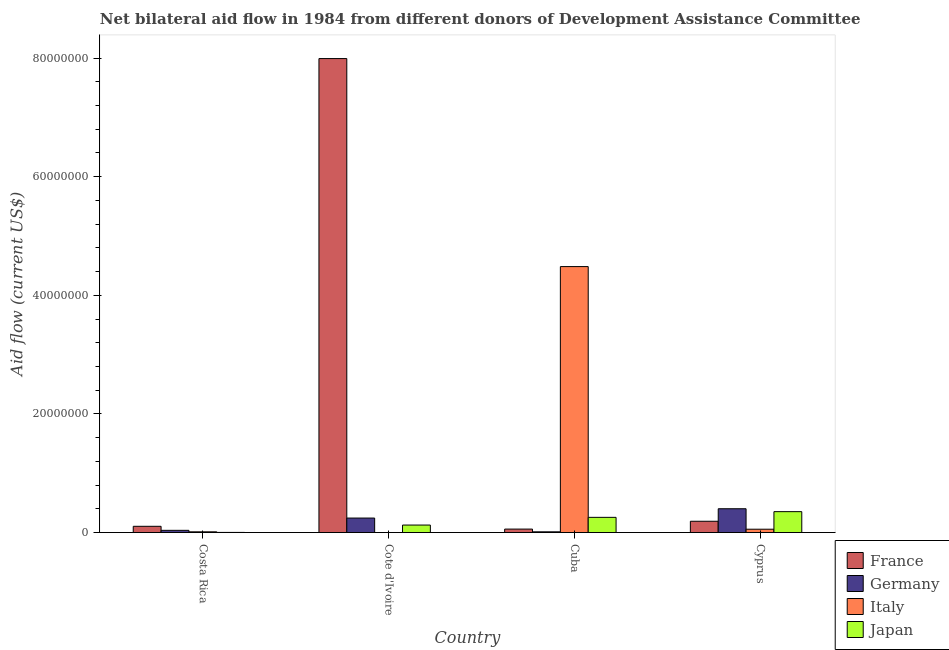How many different coloured bars are there?
Keep it short and to the point. 4. How many bars are there on the 4th tick from the left?
Offer a terse response. 4. How many bars are there on the 1st tick from the right?
Provide a succinct answer. 4. What is the label of the 4th group of bars from the left?
Make the answer very short. Cyprus. In how many cases, is the number of bars for a given country not equal to the number of legend labels?
Make the answer very short. 0. What is the amount of aid given by france in Cote d'Ivoire?
Make the answer very short. 7.99e+07. Across all countries, what is the maximum amount of aid given by germany?
Keep it short and to the point. 4.02e+06. Across all countries, what is the minimum amount of aid given by japan?
Keep it short and to the point. 3.00e+04. In which country was the amount of aid given by france maximum?
Keep it short and to the point. Cote d'Ivoire. In which country was the amount of aid given by germany minimum?
Your response must be concise. Cuba. What is the total amount of aid given by germany in the graph?
Offer a terse response. 6.98e+06. What is the difference between the amount of aid given by italy in Costa Rica and that in Cuba?
Offer a terse response. -4.47e+07. What is the difference between the amount of aid given by japan in Costa Rica and the amount of aid given by france in Cote d'Ivoire?
Your answer should be very brief. -7.99e+07. What is the average amount of aid given by germany per country?
Ensure brevity in your answer.  1.74e+06. What is the difference between the amount of aid given by france and amount of aid given by germany in Cote d'Ivoire?
Your answer should be very brief. 7.75e+07. What is the ratio of the amount of aid given by germany in Costa Rica to that in Cuba?
Offer a terse response. 2.92. What is the difference between the highest and the second highest amount of aid given by germany?
Keep it short and to the point. 1.57e+06. What is the difference between the highest and the lowest amount of aid given by france?
Offer a very short reply. 7.93e+07. In how many countries, is the amount of aid given by france greater than the average amount of aid given by france taken over all countries?
Provide a succinct answer. 1. Is it the case that in every country, the sum of the amount of aid given by japan and amount of aid given by germany is greater than the sum of amount of aid given by france and amount of aid given by italy?
Your answer should be compact. No. What does the 4th bar from the left in Costa Rica represents?
Provide a short and direct response. Japan. What does the 4th bar from the right in Cote d'Ivoire represents?
Ensure brevity in your answer.  France. Are all the bars in the graph horizontal?
Provide a succinct answer. No. What is the difference between two consecutive major ticks on the Y-axis?
Offer a very short reply. 2.00e+07. Are the values on the major ticks of Y-axis written in scientific E-notation?
Make the answer very short. No. Does the graph contain any zero values?
Keep it short and to the point. No. Does the graph contain grids?
Offer a terse response. No. Where does the legend appear in the graph?
Your answer should be compact. Bottom right. How many legend labels are there?
Give a very brief answer. 4. What is the title of the graph?
Offer a terse response. Net bilateral aid flow in 1984 from different donors of Development Assistance Committee. What is the label or title of the X-axis?
Keep it short and to the point. Country. What is the Aid flow (current US$) of France in Costa Rica?
Make the answer very short. 1.06e+06. What is the Aid flow (current US$) of Japan in Costa Rica?
Your response must be concise. 3.00e+04. What is the Aid flow (current US$) of France in Cote d'Ivoire?
Provide a short and direct response. 7.99e+07. What is the Aid flow (current US$) of Germany in Cote d'Ivoire?
Your answer should be compact. 2.45e+06. What is the Aid flow (current US$) of Japan in Cote d'Ivoire?
Ensure brevity in your answer.  1.27e+06. What is the Aid flow (current US$) in France in Cuba?
Make the answer very short. 5.90e+05. What is the Aid flow (current US$) in Germany in Cuba?
Offer a very short reply. 1.30e+05. What is the Aid flow (current US$) in Italy in Cuba?
Provide a succinct answer. 4.48e+07. What is the Aid flow (current US$) of Japan in Cuba?
Your response must be concise. 2.57e+06. What is the Aid flow (current US$) of France in Cyprus?
Your response must be concise. 1.91e+06. What is the Aid flow (current US$) of Germany in Cyprus?
Give a very brief answer. 4.02e+06. What is the Aid flow (current US$) in Italy in Cyprus?
Keep it short and to the point. 5.70e+05. What is the Aid flow (current US$) in Japan in Cyprus?
Ensure brevity in your answer.  3.53e+06. Across all countries, what is the maximum Aid flow (current US$) in France?
Your answer should be very brief. 7.99e+07. Across all countries, what is the maximum Aid flow (current US$) in Germany?
Provide a short and direct response. 4.02e+06. Across all countries, what is the maximum Aid flow (current US$) in Italy?
Offer a very short reply. 4.48e+07. Across all countries, what is the maximum Aid flow (current US$) of Japan?
Offer a terse response. 3.53e+06. Across all countries, what is the minimum Aid flow (current US$) in France?
Give a very brief answer. 5.90e+05. Across all countries, what is the minimum Aid flow (current US$) of Germany?
Ensure brevity in your answer.  1.30e+05. Across all countries, what is the minimum Aid flow (current US$) in Japan?
Make the answer very short. 3.00e+04. What is the total Aid flow (current US$) in France in the graph?
Your response must be concise. 8.35e+07. What is the total Aid flow (current US$) of Germany in the graph?
Provide a succinct answer. 6.98e+06. What is the total Aid flow (current US$) of Italy in the graph?
Your response must be concise. 4.56e+07. What is the total Aid flow (current US$) of Japan in the graph?
Offer a terse response. 7.40e+06. What is the difference between the Aid flow (current US$) in France in Costa Rica and that in Cote d'Ivoire?
Your answer should be compact. -7.89e+07. What is the difference between the Aid flow (current US$) of Germany in Costa Rica and that in Cote d'Ivoire?
Keep it short and to the point. -2.07e+06. What is the difference between the Aid flow (current US$) in Italy in Costa Rica and that in Cote d'Ivoire?
Make the answer very short. 1.20e+05. What is the difference between the Aid flow (current US$) in Japan in Costa Rica and that in Cote d'Ivoire?
Keep it short and to the point. -1.24e+06. What is the difference between the Aid flow (current US$) in France in Costa Rica and that in Cuba?
Ensure brevity in your answer.  4.70e+05. What is the difference between the Aid flow (current US$) in Italy in Costa Rica and that in Cuba?
Provide a succinct answer. -4.47e+07. What is the difference between the Aid flow (current US$) in Japan in Costa Rica and that in Cuba?
Your response must be concise. -2.54e+06. What is the difference between the Aid flow (current US$) of France in Costa Rica and that in Cyprus?
Offer a very short reply. -8.50e+05. What is the difference between the Aid flow (current US$) in Germany in Costa Rica and that in Cyprus?
Ensure brevity in your answer.  -3.64e+06. What is the difference between the Aid flow (current US$) of Italy in Costa Rica and that in Cyprus?
Provide a succinct answer. -4.40e+05. What is the difference between the Aid flow (current US$) in Japan in Costa Rica and that in Cyprus?
Offer a very short reply. -3.50e+06. What is the difference between the Aid flow (current US$) of France in Cote d'Ivoire and that in Cuba?
Keep it short and to the point. 7.93e+07. What is the difference between the Aid flow (current US$) of Germany in Cote d'Ivoire and that in Cuba?
Your answer should be compact. 2.32e+06. What is the difference between the Aid flow (current US$) in Italy in Cote d'Ivoire and that in Cuba?
Keep it short and to the point. -4.48e+07. What is the difference between the Aid flow (current US$) of Japan in Cote d'Ivoire and that in Cuba?
Provide a short and direct response. -1.30e+06. What is the difference between the Aid flow (current US$) in France in Cote d'Ivoire and that in Cyprus?
Provide a succinct answer. 7.80e+07. What is the difference between the Aid flow (current US$) in Germany in Cote d'Ivoire and that in Cyprus?
Offer a very short reply. -1.57e+06. What is the difference between the Aid flow (current US$) of Italy in Cote d'Ivoire and that in Cyprus?
Your response must be concise. -5.60e+05. What is the difference between the Aid flow (current US$) of Japan in Cote d'Ivoire and that in Cyprus?
Your response must be concise. -2.26e+06. What is the difference between the Aid flow (current US$) of France in Cuba and that in Cyprus?
Offer a very short reply. -1.32e+06. What is the difference between the Aid flow (current US$) of Germany in Cuba and that in Cyprus?
Ensure brevity in your answer.  -3.89e+06. What is the difference between the Aid flow (current US$) of Italy in Cuba and that in Cyprus?
Keep it short and to the point. 4.43e+07. What is the difference between the Aid flow (current US$) of Japan in Cuba and that in Cyprus?
Your response must be concise. -9.60e+05. What is the difference between the Aid flow (current US$) in France in Costa Rica and the Aid flow (current US$) in Germany in Cote d'Ivoire?
Provide a short and direct response. -1.39e+06. What is the difference between the Aid flow (current US$) of France in Costa Rica and the Aid flow (current US$) of Italy in Cote d'Ivoire?
Ensure brevity in your answer.  1.05e+06. What is the difference between the Aid flow (current US$) in Germany in Costa Rica and the Aid flow (current US$) in Italy in Cote d'Ivoire?
Provide a short and direct response. 3.70e+05. What is the difference between the Aid flow (current US$) of Germany in Costa Rica and the Aid flow (current US$) of Japan in Cote d'Ivoire?
Your response must be concise. -8.90e+05. What is the difference between the Aid flow (current US$) in Italy in Costa Rica and the Aid flow (current US$) in Japan in Cote d'Ivoire?
Ensure brevity in your answer.  -1.14e+06. What is the difference between the Aid flow (current US$) of France in Costa Rica and the Aid flow (current US$) of Germany in Cuba?
Your answer should be very brief. 9.30e+05. What is the difference between the Aid flow (current US$) of France in Costa Rica and the Aid flow (current US$) of Italy in Cuba?
Keep it short and to the point. -4.38e+07. What is the difference between the Aid flow (current US$) of France in Costa Rica and the Aid flow (current US$) of Japan in Cuba?
Give a very brief answer. -1.51e+06. What is the difference between the Aid flow (current US$) of Germany in Costa Rica and the Aid flow (current US$) of Italy in Cuba?
Keep it short and to the point. -4.45e+07. What is the difference between the Aid flow (current US$) in Germany in Costa Rica and the Aid flow (current US$) in Japan in Cuba?
Keep it short and to the point. -2.19e+06. What is the difference between the Aid flow (current US$) of Italy in Costa Rica and the Aid flow (current US$) of Japan in Cuba?
Give a very brief answer. -2.44e+06. What is the difference between the Aid flow (current US$) in France in Costa Rica and the Aid flow (current US$) in Germany in Cyprus?
Ensure brevity in your answer.  -2.96e+06. What is the difference between the Aid flow (current US$) of France in Costa Rica and the Aid flow (current US$) of Italy in Cyprus?
Provide a short and direct response. 4.90e+05. What is the difference between the Aid flow (current US$) of France in Costa Rica and the Aid flow (current US$) of Japan in Cyprus?
Keep it short and to the point. -2.47e+06. What is the difference between the Aid flow (current US$) in Germany in Costa Rica and the Aid flow (current US$) in Japan in Cyprus?
Ensure brevity in your answer.  -3.15e+06. What is the difference between the Aid flow (current US$) in Italy in Costa Rica and the Aid flow (current US$) in Japan in Cyprus?
Provide a succinct answer. -3.40e+06. What is the difference between the Aid flow (current US$) in France in Cote d'Ivoire and the Aid flow (current US$) in Germany in Cuba?
Your answer should be very brief. 7.98e+07. What is the difference between the Aid flow (current US$) in France in Cote d'Ivoire and the Aid flow (current US$) in Italy in Cuba?
Your answer should be compact. 3.51e+07. What is the difference between the Aid flow (current US$) of France in Cote d'Ivoire and the Aid flow (current US$) of Japan in Cuba?
Your answer should be compact. 7.74e+07. What is the difference between the Aid flow (current US$) of Germany in Cote d'Ivoire and the Aid flow (current US$) of Italy in Cuba?
Make the answer very short. -4.24e+07. What is the difference between the Aid flow (current US$) of Italy in Cote d'Ivoire and the Aid flow (current US$) of Japan in Cuba?
Offer a terse response. -2.56e+06. What is the difference between the Aid flow (current US$) in France in Cote d'Ivoire and the Aid flow (current US$) in Germany in Cyprus?
Your answer should be compact. 7.59e+07. What is the difference between the Aid flow (current US$) in France in Cote d'Ivoire and the Aid flow (current US$) in Italy in Cyprus?
Provide a succinct answer. 7.94e+07. What is the difference between the Aid flow (current US$) in France in Cote d'Ivoire and the Aid flow (current US$) in Japan in Cyprus?
Provide a short and direct response. 7.64e+07. What is the difference between the Aid flow (current US$) of Germany in Cote d'Ivoire and the Aid flow (current US$) of Italy in Cyprus?
Provide a short and direct response. 1.88e+06. What is the difference between the Aid flow (current US$) in Germany in Cote d'Ivoire and the Aid flow (current US$) in Japan in Cyprus?
Provide a succinct answer. -1.08e+06. What is the difference between the Aid flow (current US$) in Italy in Cote d'Ivoire and the Aid flow (current US$) in Japan in Cyprus?
Keep it short and to the point. -3.52e+06. What is the difference between the Aid flow (current US$) in France in Cuba and the Aid flow (current US$) in Germany in Cyprus?
Provide a succinct answer. -3.43e+06. What is the difference between the Aid flow (current US$) of France in Cuba and the Aid flow (current US$) of Italy in Cyprus?
Make the answer very short. 2.00e+04. What is the difference between the Aid flow (current US$) in France in Cuba and the Aid flow (current US$) in Japan in Cyprus?
Provide a short and direct response. -2.94e+06. What is the difference between the Aid flow (current US$) in Germany in Cuba and the Aid flow (current US$) in Italy in Cyprus?
Offer a terse response. -4.40e+05. What is the difference between the Aid flow (current US$) of Germany in Cuba and the Aid flow (current US$) of Japan in Cyprus?
Ensure brevity in your answer.  -3.40e+06. What is the difference between the Aid flow (current US$) of Italy in Cuba and the Aid flow (current US$) of Japan in Cyprus?
Your answer should be very brief. 4.13e+07. What is the average Aid flow (current US$) in France per country?
Ensure brevity in your answer.  2.09e+07. What is the average Aid flow (current US$) of Germany per country?
Offer a terse response. 1.74e+06. What is the average Aid flow (current US$) in Italy per country?
Offer a terse response. 1.14e+07. What is the average Aid flow (current US$) of Japan per country?
Ensure brevity in your answer.  1.85e+06. What is the difference between the Aid flow (current US$) in France and Aid flow (current US$) in Germany in Costa Rica?
Keep it short and to the point. 6.80e+05. What is the difference between the Aid flow (current US$) of France and Aid flow (current US$) of Italy in Costa Rica?
Keep it short and to the point. 9.30e+05. What is the difference between the Aid flow (current US$) of France and Aid flow (current US$) of Japan in Costa Rica?
Provide a succinct answer. 1.03e+06. What is the difference between the Aid flow (current US$) in Italy and Aid flow (current US$) in Japan in Costa Rica?
Offer a very short reply. 1.00e+05. What is the difference between the Aid flow (current US$) of France and Aid flow (current US$) of Germany in Cote d'Ivoire?
Give a very brief answer. 7.75e+07. What is the difference between the Aid flow (current US$) of France and Aid flow (current US$) of Italy in Cote d'Ivoire?
Your answer should be very brief. 7.99e+07. What is the difference between the Aid flow (current US$) in France and Aid flow (current US$) in Japan in Cote d'Ivoire?
Your answer should be compact. 7.86e+07. What is the difference between the Aid flow (current US$) in Germany and Aid flow (current US$) in Italy in Cote d'Ivoire?
Offer a very short reply. 2.44e+06. What is the difference between the Aid flow (current US$) in Germany and Aid flow (current US$) in Japan in Cote d'Ivoire?
Your answer should be compact. 1.18e+06. What is the difference between the Aid flow (current US$) in Italy and Aid flow (current US$) in Japan in Cote d'Ivoire?
Your answer should be compact. -1.26e+06. What is the difference between the Aid flow (current US$) in France and Aid flow (current US$) in Italy in Cuba?
Make the answer very short. -4.43e+07. What is the difference between the Aid flow (current US$) of France and Aid flow (current US$) of Japan in Cuba?
Keep it short and to the point. -1.98e+06. What is the difference between the Aid flow (current US$) in Germany and Aid flow (current US$) in Italy in Cuba?
Offer a terse response. -4.47e+07. What is the difference between the Aid flow (current US$) of Germany and Aid flow (current US$) of Japan in Cuba?
Ensure brevity in your answer.  -2.44e+06. What is the difference between the Aid flow (current US$) in Italy and Aid flow (current US$) in Japan in Cuba?
Provide a succinct answer. 4.23e+07. What is the difference between the Aid flow (current US$) of France and Aid flow (current US$) of Germany in Cyprus?
Offer a terse response. -2.11e+06. What is the difference between the Aid flow (current US$) in France and Aid flow (current US$) in Italy in Cyprus?
Offer a very short reply. 1.34e+06. What is the difference between the Aid flow (current US$) of France and Aid flow (current US$) of Japan in Cyprus?
Offer a very short reply. -1.62e+06. What is the difference between the Aid flow (current US$) of Germany and Aid flow (current US$) of Italy in Cyprus?
Make the answer very short. 3.45e+06. What is the difference between the Aid flow (current US$) in Italy and Aid flow (current US$) in Japan in Cyprus?
Make the answer very short. -2.96e+06. What is the ratio of the Aid flow (current US$) in France in Costa Rica to that in Cote d'Ivoire?
Provide a short and direct response. 0.01. What is the ratio of the Aid flow (current US$) of Germany in Costa Rica to that in Cote d'Ivoire?
Make the answer very short. 0.16. What is the ratio of the Aid flow (current US$) in Japan in Costa Rica to that in Cote d'Ivoire?
Give a very brief answer. 0.02. What is the ratio of the Aid flow (current US$) of France in Costa Rica to that in Cuba?
Your response must be concise. 1.8. What is the ratio of the Aid flow (current US$) in Germany in Costa Rica to that in Cuba?
Ensure brevity in your answer.  2.92. What is the ratio of the Aid flow (current US$) in Italy in Costa Rica to that in Cuba?
Give a very brief answer. 0. What is the ratio of the Aid flow (current US$) of Japan in Costa Rica to that in Cuba?
Offer a very short reply. 0.01. What is the ratio of the Aid flow (current US$) in France in Costa Rica to that in Cyprus?
Offer a terse response. 0.56. What is the ratio of the Aid flow (current US$) in Germany in Costa Rica to that in Cyprus?
Give a very brief answer. 0.09. What is the ratio of the Aid flow (current US$) in Italy in Costa Rica to that in Cyprus?
Offer a terse response. 0.23. What is the ratio of the Aid flow (current US$) in Japan in Costa Rica to that in Cyprus?
Your answer should be very brief. 0.01. What is the ratio of the Aid flow (current US$) in France in Cote d'Ivoire to that in Cuba?
Offer a terse response. 135.46. What is the ratio of the Aid flow (current US$) in Germany in Cote d'Ivoire to that in Cuba?
Give a very brief answer. 18.85. What is the ratio of the Aid flow (current US$) of Italy in Cote d'Ivoire to that in Cuba?
Offer a very short reply. 0. What is the ratio of the Aid flow (current US$) in Japan in Cote d'Ivoire to that in Cuba?
Provide a short and direct response. 0.49. What is the ratio of the Aid flow (current US$) in France in Cote d'Ivoire to that in Cyprus?
Provide a succinct answer. 41.84. What is the ratio of the Aid flow (current US$) in Germany in Cote d'Ivoire to that in Cyprus?
Provide a succinct answer. 0.61. What is the ratio of the Aid flow (current US$) of Italy in Cote d'Ivoire to that in Cyprus?
Provide a short and direct response. 0.02. What is the ratio of the Aid flow (current US$) of Japan in Cote d'Ivoire to that in Cyprus?
Make the answer very short. 0.36. What is the ratio of the Aid flow (current US$) in France in Cuba to that in Cyprus?
Ensure brevity in your answer.  0.31. What is the ratio of the Aid flow (current US$) in Germany in Cuba to that in Cyprus?
Provide a short and direct response. 0.03. What is the ratio of the Aid flow (current US$) in Italy in Cuba to that in Cyprus?
Your answer should be compact. 78.68. What is the ratio of the Aid flow (current US$) of Japan in Cuba to that in Cyprus?
Offer a very short reply. 0.73. What is the difference between the highest and the second highest Aid flow (current US$) in France?
Provide a succinct answer. 7.80e+07. What is the difference between the highest and the second highest Aid flow (current US$) in Germany?
Your response must be concise. 1.57e+06. What is the difference between the highest and the second highest Aid flow (current US$) in Italy?
Provide a succinct answer. 4.43e+07. What is the difference between the highest and the second highest Aid flow (current US$) in Japan?
Keep it short and to the point. 9.60e+05. What is the difference between the highest and the lowest Aid flow (current US$) in France?
Provide a succinct answer. 7.93e+07. What is the difference between the highest and the lowest Aid flow (current US$) of Germany?
Give a very brief answer. 3.89e+06. What is the difference between the highest and the lowest Aid flow (current US$) in Italy?
Ensure brevity in your answer.  4.48e+07. What is the difference between the highest and the lowest Aid flow (current US$) in Japan?
Your answer should be very brief. 3.50e+06. 